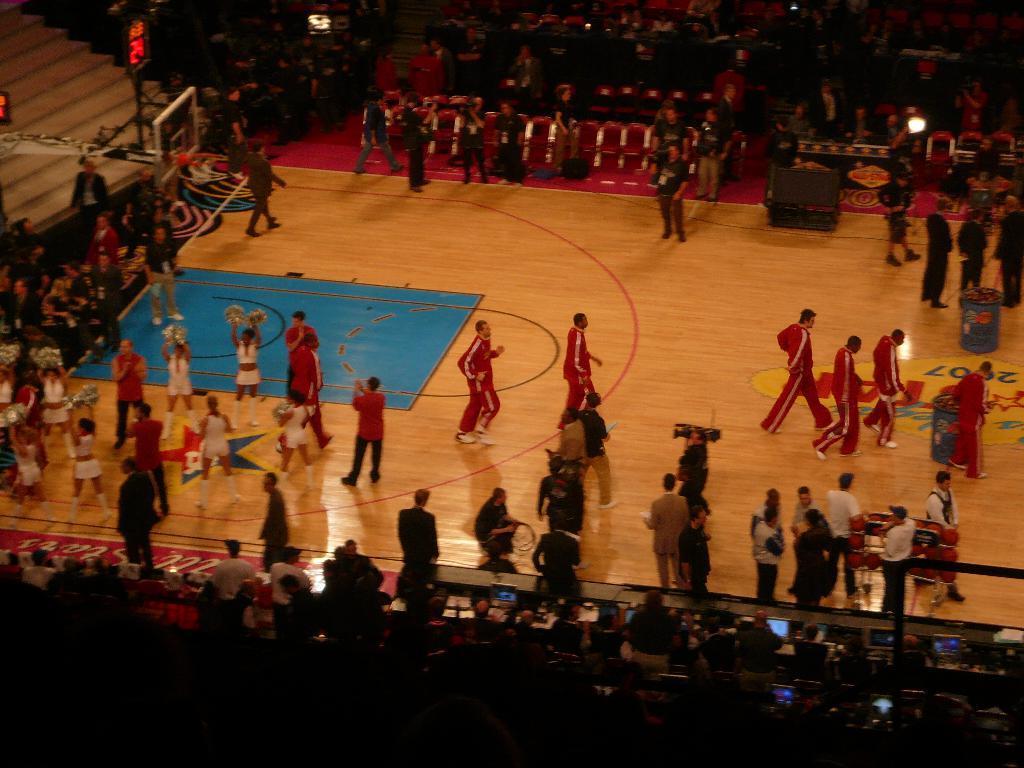In one or two sentences, can you explain what this image depicts? In this image we can see a few people on the basketball court. At the top we can see a group of people sitting on the chairs and few people taking videos. At the bottom we can see few people and electronic gadgets on a table. On the left side, we can see a basketball goal and a board with digital text. 